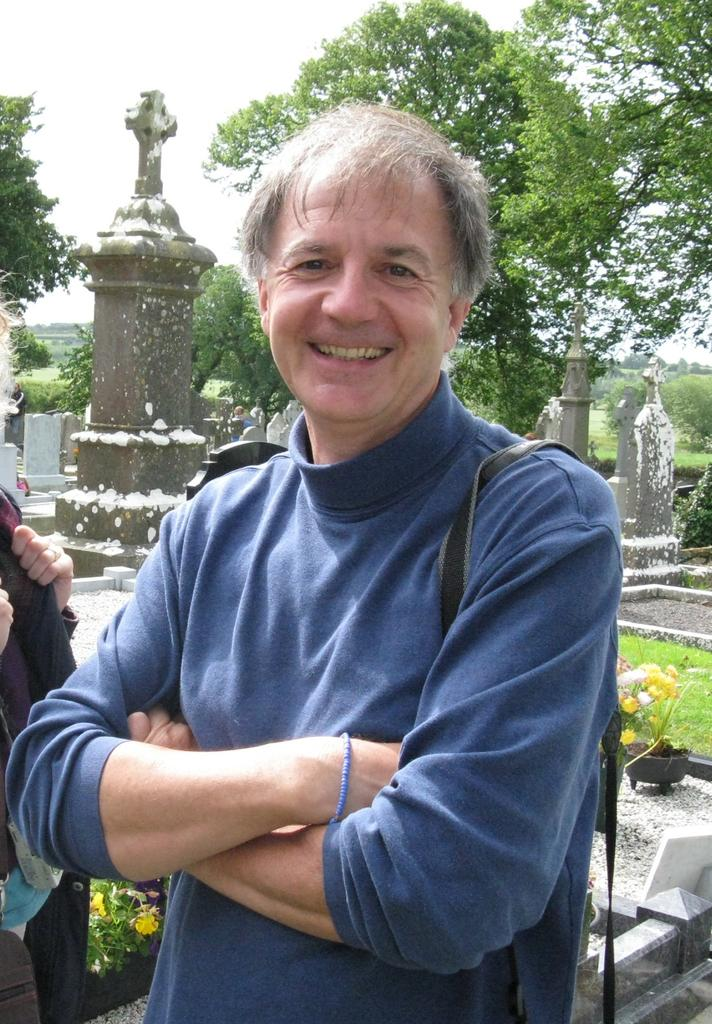Who or what can be seen in the image? There are people in the image. What is the surface that the people are standing on? The ground is visible in the image. What type of location is depicted in the image? There are graves in the image, suggesting a cemetery or memorial site. What type of vegetation is present in the image? Plants, flowers, and trees are present in the image. What part of the natural environment is visible in the image? The sky is visible in the image. What type of jam is being served at the graveside in the image? There is no jam present in the image; it is a cemetery or memorial site with people, graves, plants, flowers, trees, and the sky visible. 